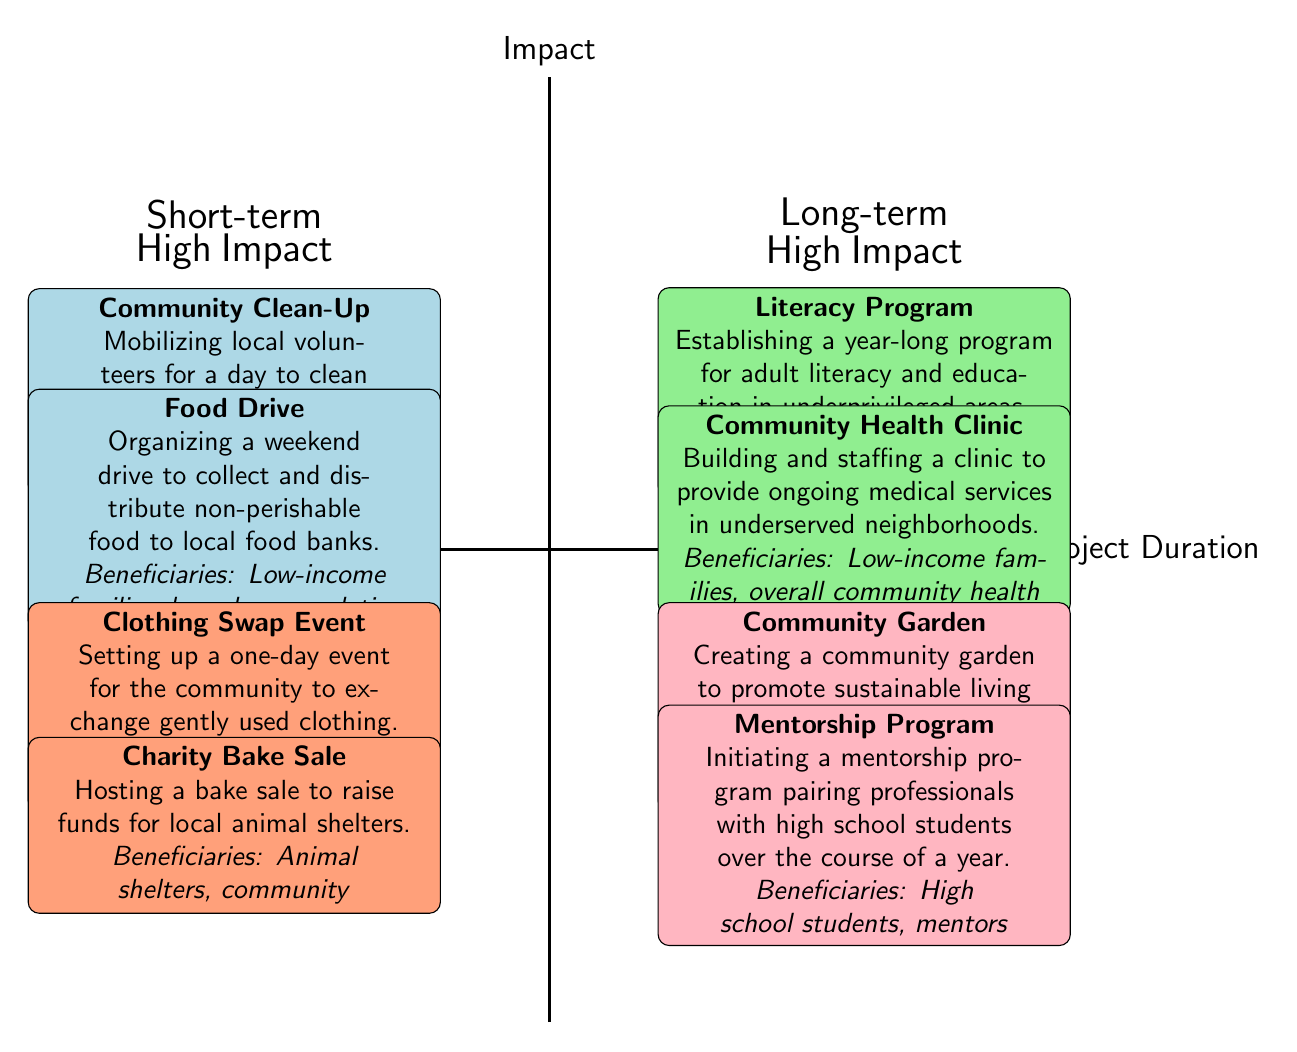What are the names of the two Short-term High Impact projects? The two Short-term High Impact projects listed in the diagram are "Community Clean-Up" and "Food Drive," both identified in the upper left quadrant of the chart.
Answer: Community Clean-Up, Food Drive How many Low Impact projects are there in total? Counting the Low Impact projects from both the Short-term and Long-term quadrants, there are four in total: two from Short-term and two from Long-term.
Answer: 4 Which project has beneficiaries that include "undereducated adults"? The project that focuses on "undereducated adults" is "Literacy Program," located in the upper right quadrant, which represents Long-term High Impact projects.
Answer: Literacy Program What type of projects are placed in the bottom left quadrant? The bottom left quadrant contains Short-term Low Impact projects. This includes initiatives that have a shorter duration and lesser impact as represented visually in the diagram.
Answer: Short-term Low Impact Which quadrant contains "Community Garden" and what is its impact classification? "Community Garden" is located in the lower right quadrant, which is designated for Long-term Low Impact projects. Its position reflects its longer duration but lesser impact relative to other projects.
Answer: Long-term Low Impact Which project aims to provide ongoing medical services? The project aiming to provide ongoing medical services is "Community Health Clinic," found in the Long-term High Impact quadrant, indicating its significant positive impact over a prolonged period.
Answer: Community Health Clinic How many projects are categorized as Long-term High Impact? There are two projects categorized as Long-term High Impact: "Literacy Program" and "Community Health Clinic." This information can be derived from counting the projects in the upper right quadrant.
Answer: 2 What is the primary beneficiary group for the "Food Drive"? The primary beneficiary group for the "Food Drive" is "Low-income families, homeless population," which indicates the demographic that benefits the most from this Short-term High Impact project.
Answer: Low-income families, homeless population What type of impact do projects in the upper left quadrant have? Projects located in the upper left quadrant exhibit High Impact with a Short-term duration. This classification emphasizes that these projects can bring significant benefits in a short time frame.
Answer: High Impact 